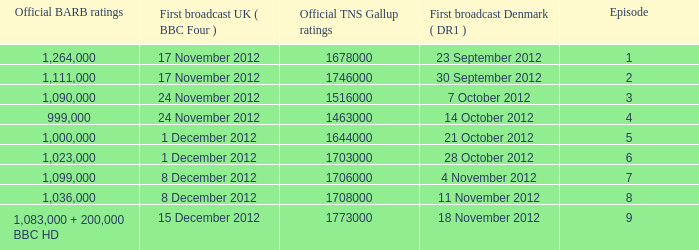What is the BARB ratings of episode 6? 1023000.0. Could you help me parse every detail presented in this table? {'header': ['Official BARB ratings', 'First broadcast UK ( BBC Four )', 'Official TNS Gallup ratings', 'First broadcast Denmark ( DR1 )', 'Episode'], 'rows': [['1,264,000', '17 November 2012', '1678000', '23 September 2012', '1'], ['1,111,000', '17 November 2012', '1746000', '30 September 2012', '2'], ['1,090,000', '24 November 2012', '1516000', '7 October 2012', '3'], ['999,000', '24 November 2012', '1463000', '14 October 2012', '4'], ['1,000,000', '1 December 2012', '1644000', '21 October 2012', '5'], ['1,023,000', '1 December 2012', '1703000', '28 October 2012', '6'], ['1,099,000', '8 December 2012', '1706000', '4 November 2012', '7'], ['1,036,000', '8 December 2012', '1708000', '11 November 2012', '8'], ['1,083,000 + 200,000 BBC HD', '15 December 2012', '1773000', '18 November 2012', '9']]} 